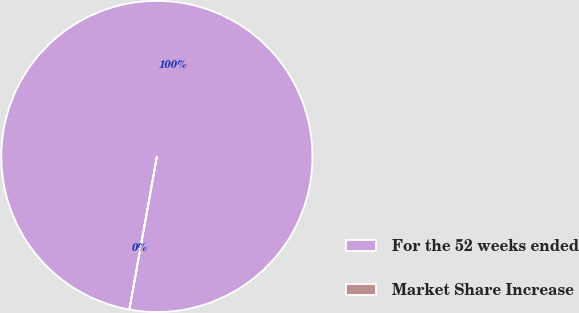Convert chart. <chart><loc_0><loc_0><loc_500><loc_500><pie_chart><fcel>For the 52 weeks ended<fcel>Market Share Increase<nl><fcel>100.0%<fcel>0.0%<nl></chart> 